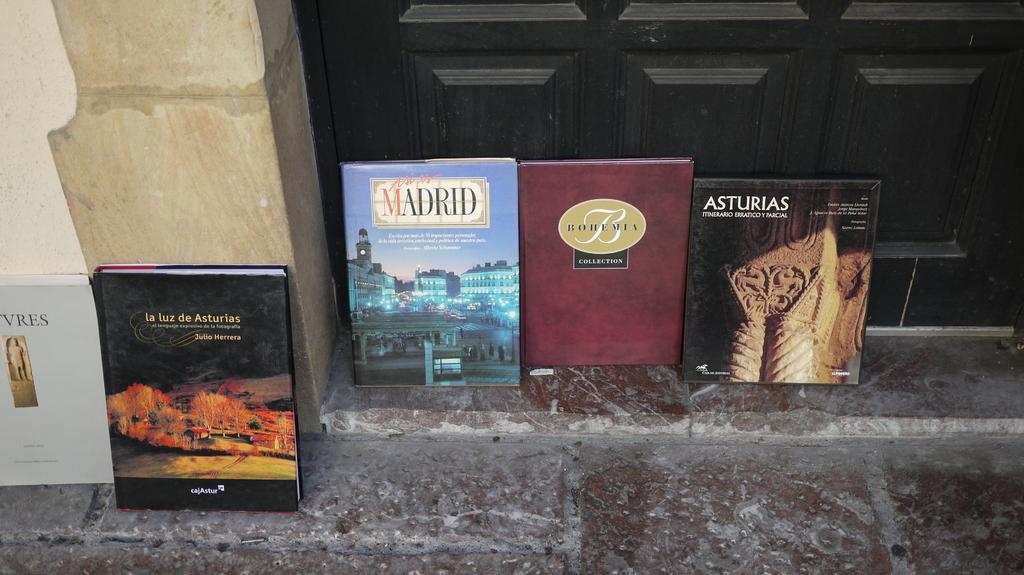<image>
Give a short and clear explanation of the subsequent image. Asturias, Madrid, Bohemia,  and La luz de Asturia collection. 